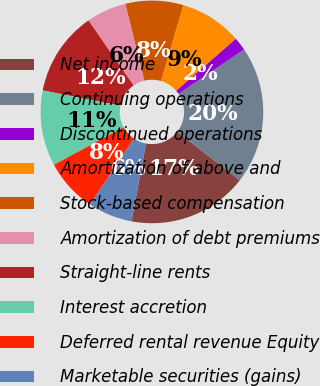Convert chart. <chart><loc_0><loc_0><loc_500><loc_500><pie_chart><fcel>Net income<fcel>Continuing operations<fcel>Discontinued operations<fcel>Amortization of above and<fcel>Stock-based compensation<fcel>Amortization of debt premiums<fcel>Straight-line rents<fcel>Interest accretion<fcel>Deferred rental revenue Equity<fcel>Marketable securities (gains)<nl><fcel>17.42%<fcel>20.0%<fcel>1.94%<fcel>9.03%<fcel>8.39%<fcel>5.81%<fcel>12.26%<fcel>10.97%<fcel>7.74%<fcel>6.45%<nl></chart> 